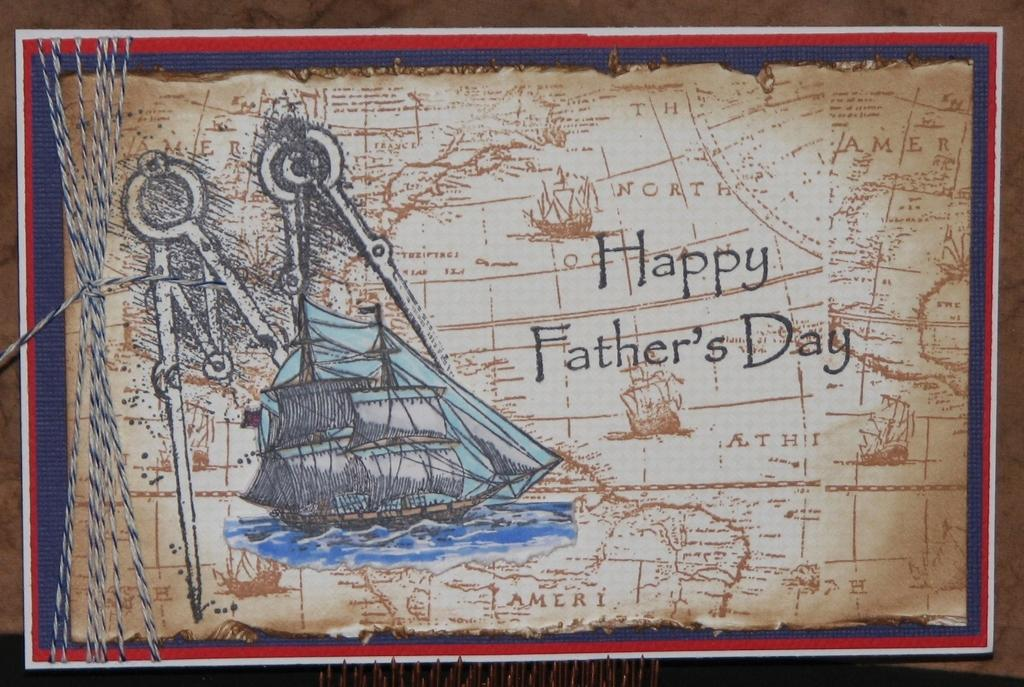What is the main subject of the image? The main subject of the image is a map. What can be found on the map? The map has text on it, an image of a ship, and a compass. Are there any additional elements in the image? Yes, there are a few threads in the image. What is visible in the background of the image? There is a table in the background of the image. How much does the company pay for the dime in the image? There is no company or dime present in the image; it only features a map with various elements on it. Is there any hair visible in the image? There is no hair visible in the image; it only features a map with various elements on it. 